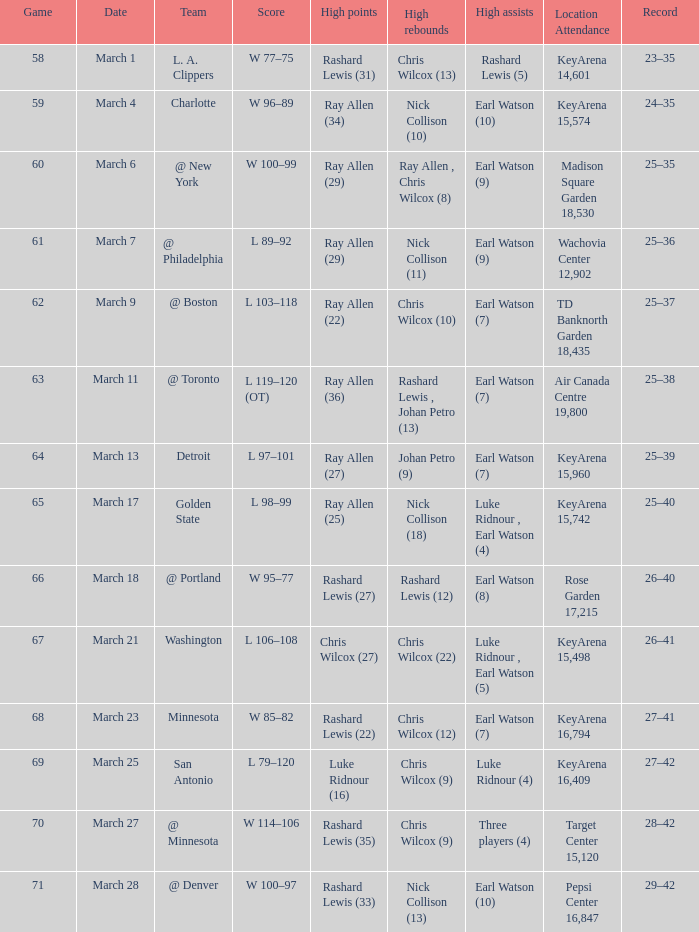Who had the most points in the game on March 7? Ray Allen (29). 